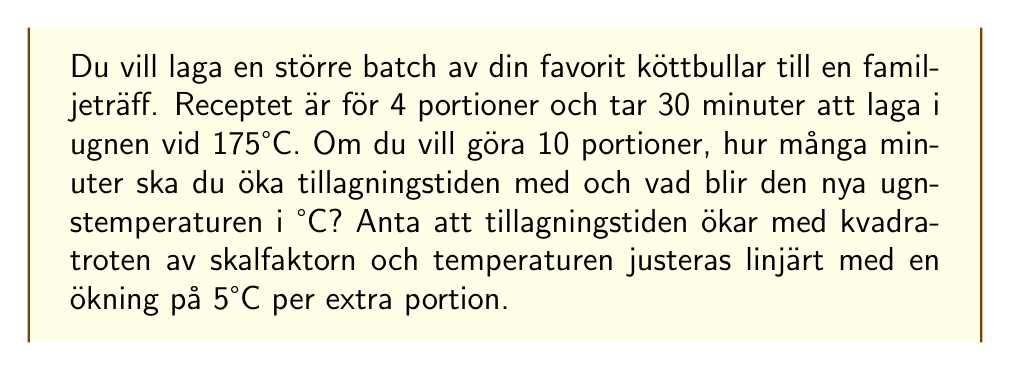What is the answer to this math problem? 1. Beräkna skalfaktorn:
   $\text{Skalfaktor} = \frac{\text{Nya portioner}}{\text{Ursprungliga portioner}} = \frac{10}{4} = 2.5$

2. Beräkna den nya tillagningstiden:
   $\text{Ny tid} = \text{Ursprunglig tid} \times \sqrt{\text{Skalfaktor}}$
   $\text{Ny tid} = 30 \times \sqrt{2.5} \approx 47.43 \text{ minuter}$

3. Beräkna ökningen i tillagningstid:
   $\text{Tidsökning} = \text{Ny tid} - \text{Ursprunglig tid}$
   $\text{Tidsökning} = 47.43 - 30 \approx 17.43 \text{ minuter}$

4. Beräkna temperaturökningen:
   $\text{Temperaturökning} = 5°\text{C} \times (\text{Nya portioner} - \text{Ursprungliga portioner})$
   $\text{Temperaturökning} = 5 \times (10 - 4) = 30°\text{C}$

5. Beräkna den nya ugnstemperaturen:
   $\text{Ny temperatur} = \text{Ursprunglig temperatur} + \text{Temperaturökning}$
   $\text{Ny temperatur} = 175°\text{C} + 30°\text{C} = 205°\text{C}$
Answer: 17 minuter, 205°C 